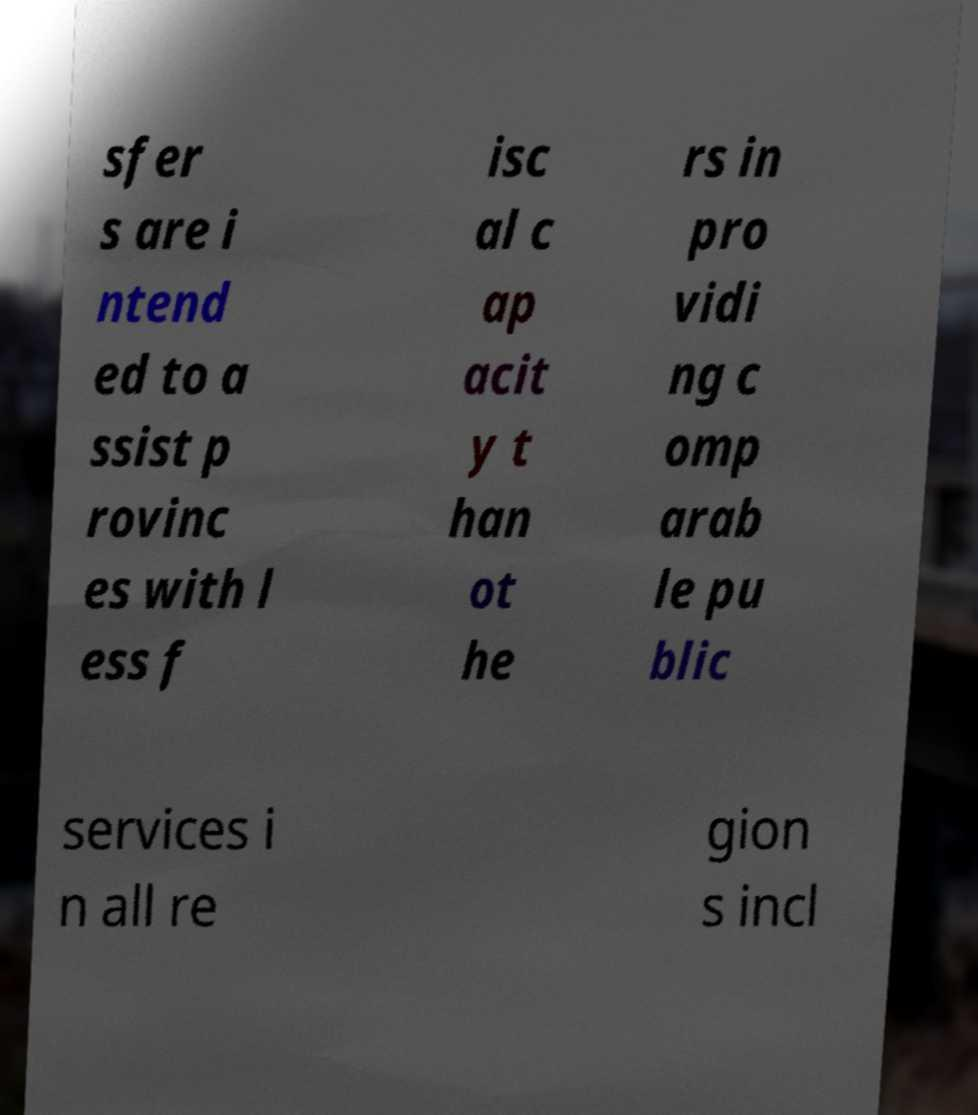Please identify and transcribe the text found in this image. sfer s are i ntend ed to a ssist p rovinc es with l ess f isc al c ap acit y t han ot he rs in pro vidi ng c omp arab le pu blic services i n all re gion s incl 